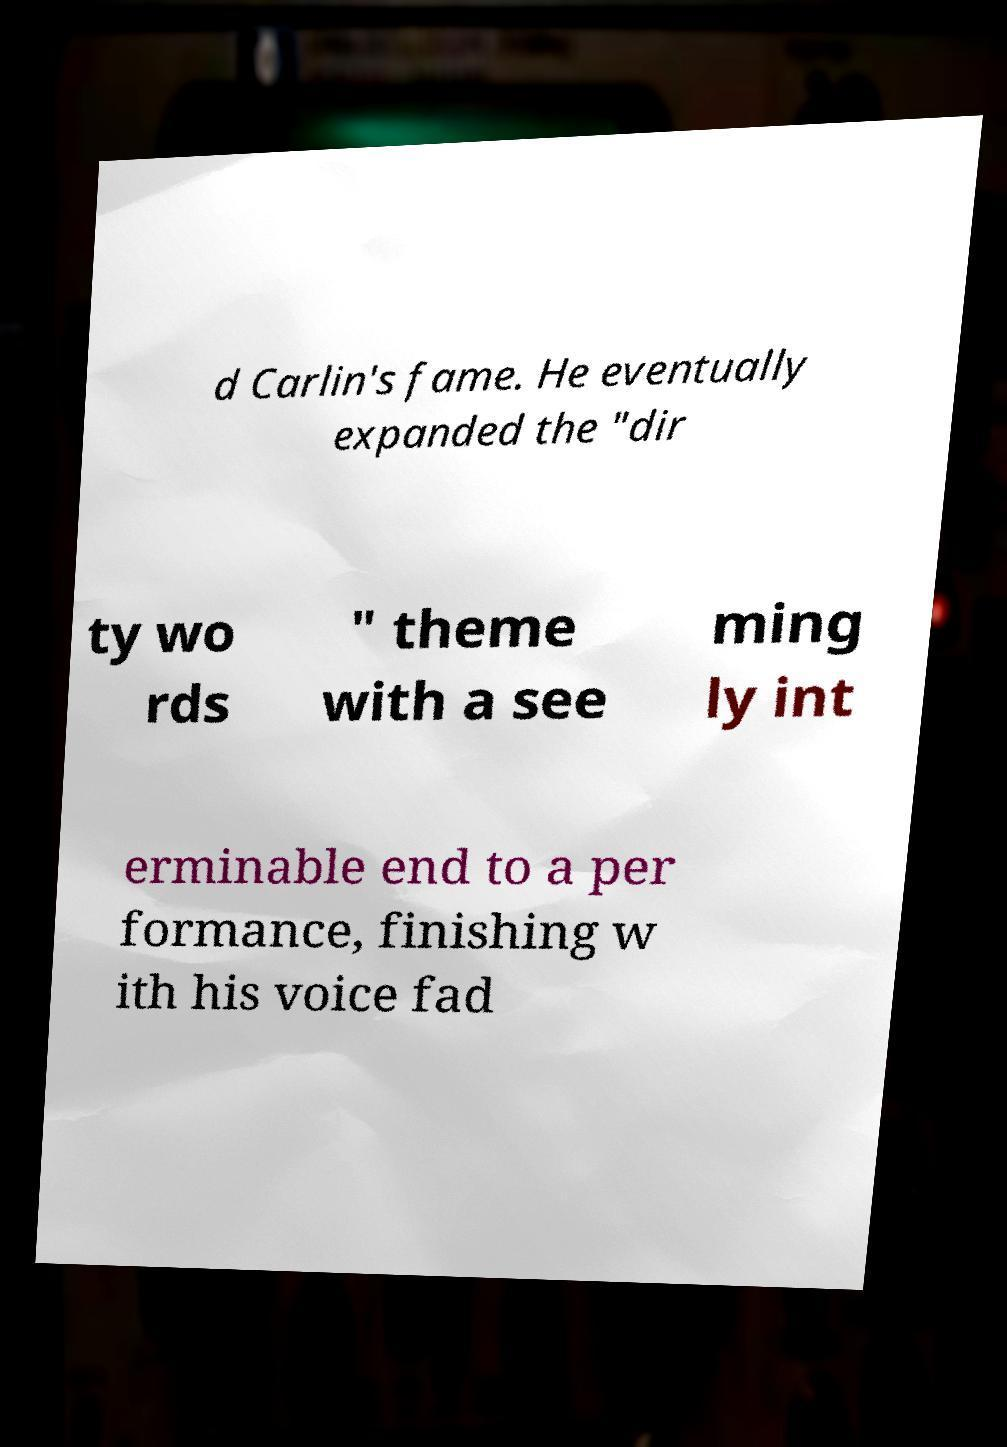For documentation purposes, I need the text within this image transcribed. Could you provide that? d Carlin's fame. He eventually expanded the "dir ty wo rds " theme with a see ming ly int erminable end to a per formance, finishing w ith his voice fad 